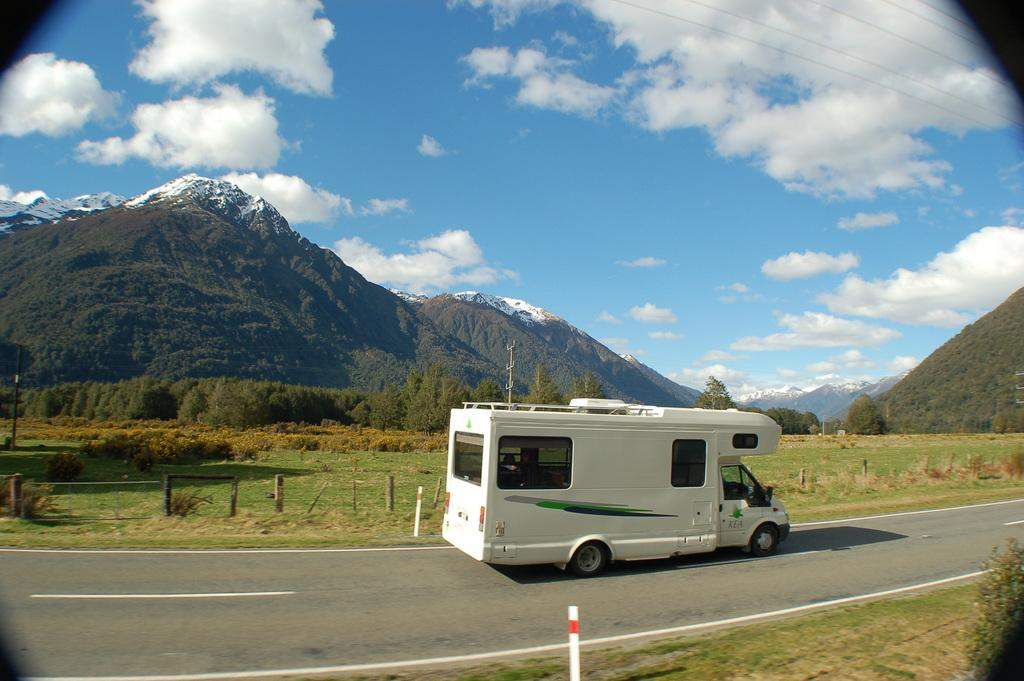What type of vehicle is on the road in the image? There is a van on the road in the image. What natural features can be seen in the background of the image? Mountains and trees are visible in the image. What man-made structures can be seen in the image? Poles are present in the image. What type of vegetation is present in the image besides trees? Small bushes are present in the image. What is visible in the sky in the image? Clouds are visible in the sky in the image. What account number is written on the van in the image? There is no account number visible on the van in the image. What discovery was made by the people in the image? There are no people present in the image, so no discovery can be attributed to them. 